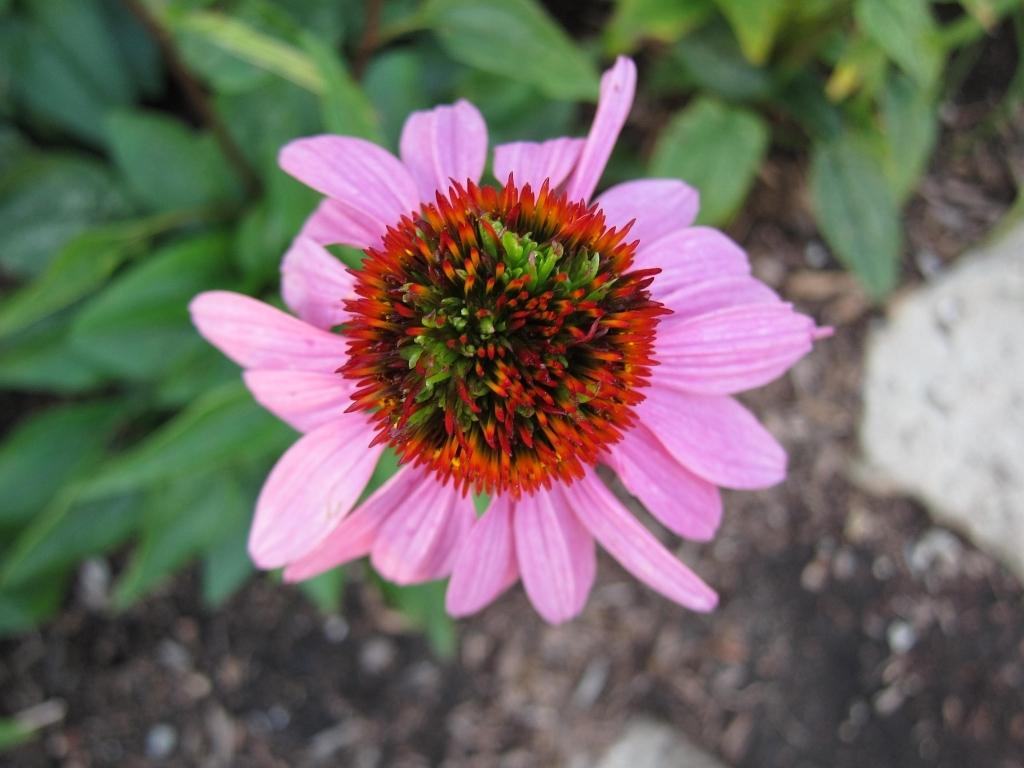What type of flower is on the plant in the image? There is a pink flower on the plant in the image. What else can be seen in the background of the image? There are other plants and stones on the ground in the background of the image. Are there any other objects on the ground in the background of the image? Yes, there are other objects on the ground in the background of the image. What type of knot is used to secure the plant to the ground in the image? There is no knot visible in the image, as the plant is not secured to the ground. 